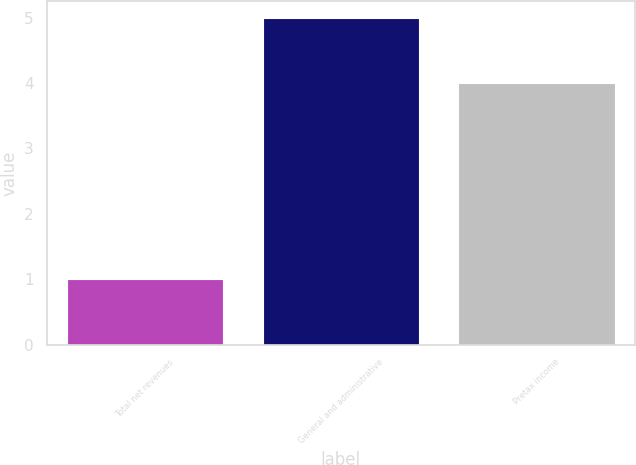Convert chart to OTSL. <chart><loc_0><loc_0><loc_500><loc_500><bar_chart><fcel>Total net revenues<fcel>General and administrative<fcel>Pretax income<nl><fcel>1<fcel>5<fcel>4<nl></chart> 